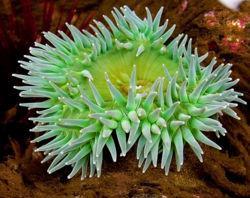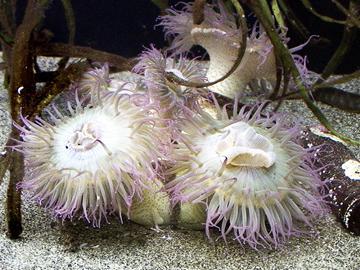The first image is the image on the left, the second image is the image on the right. Assess this claim about the two images: "At least one of the images shows more than one anemone.". Correct or not? Answer yes or no. Yes. The first image is the image on the left, the second image is the image on the right. Examine the images to the left and right. Is the description "The base of the anemone is red in the image on the right." accurate? Answer yes or no. No. 